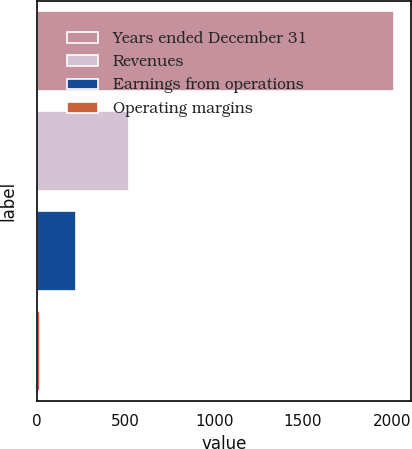<chart> <loc_0><loc_0><loc_500><loc_500><bar_chart><fcel>Years ended December 31<fcel>Revenues<fcel>Earnings from operations<fcel>Operating margins<nl><fcel>2011<fcel>520<fcel>220.9<fcel>22<nl></chart> 